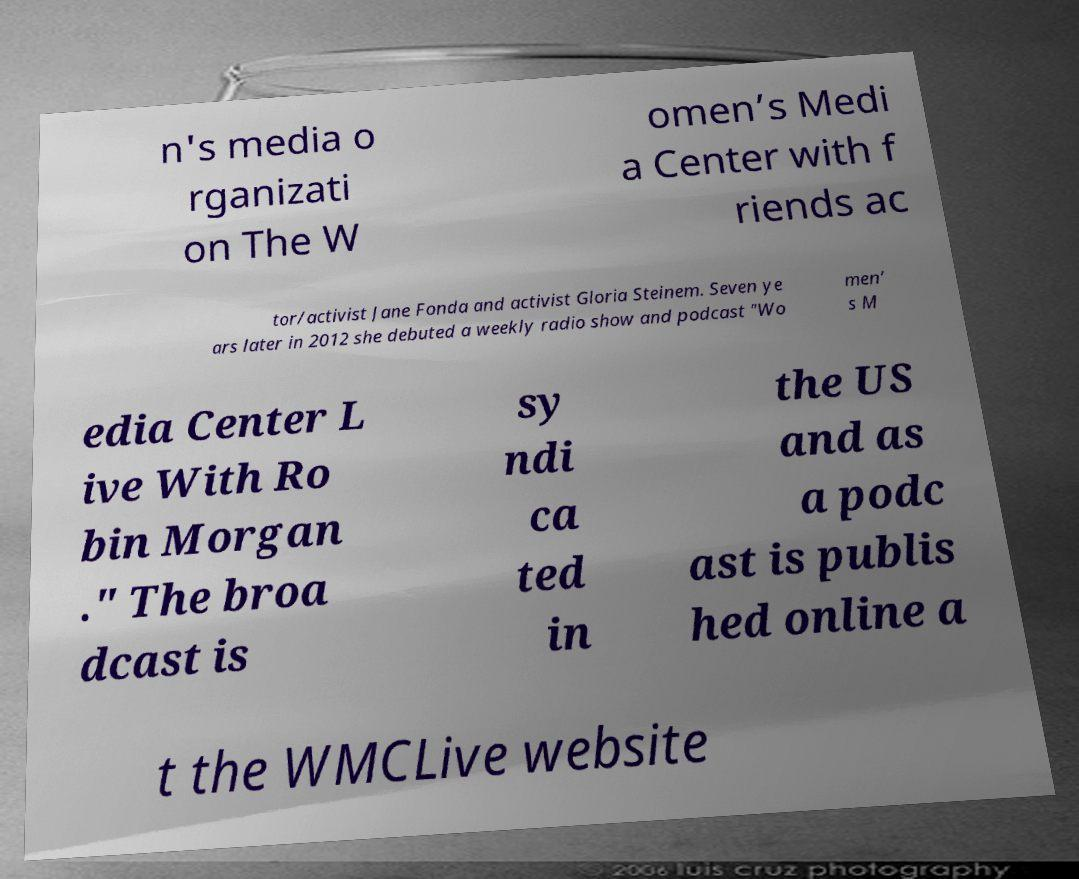I need the written content from this picture converted into text. Can you do that? n's media o rganizati on The W omen’s Medi a Center with f riends ac tor/activist Jane Fonda and activist Gloria Steinem. Seven ye ars later in 2012 she debuted a weekly radio show and podcast "Wo men’ s M edia Center L ive With Ro bin Morgan ." The broa dcast is sy ndi ca ted in the US and as a podc ast is publis hed online a t the WMCLive website 